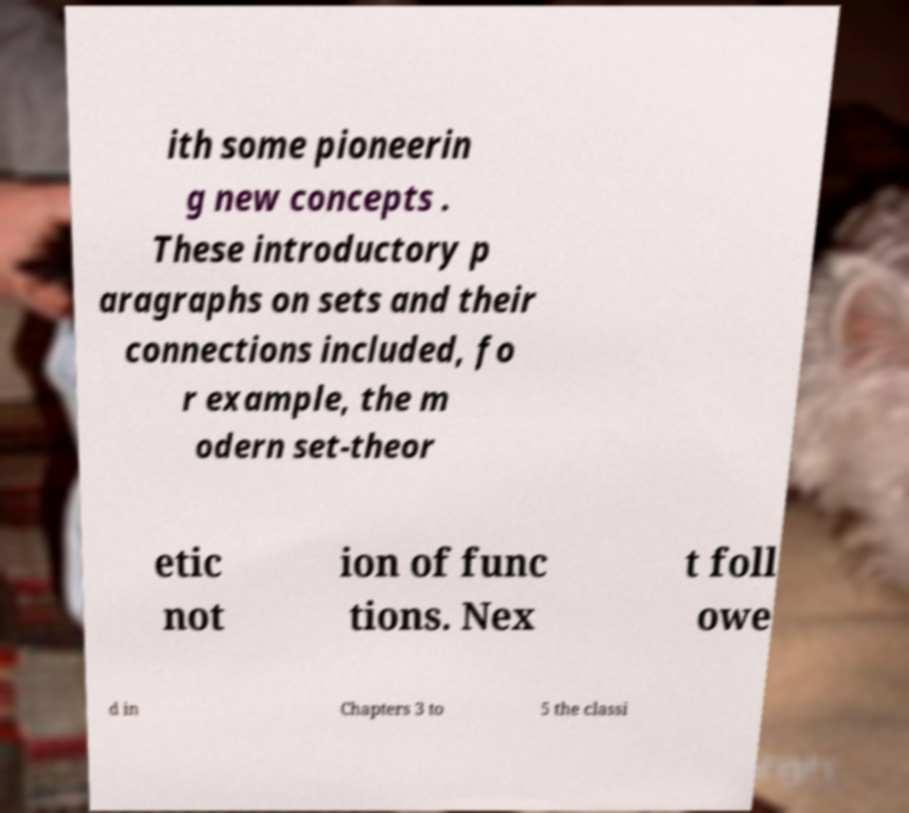For documentation purposes, I need the text within this image transcribed. Could you provide that? ith some pioneerin g new concepts . These introductory p aragraphs on sets and their connections included, fo r example, the m odern set-theor etic not ion of func tions. Nex t foll owe d in Chapters 3 to 5 the classi 